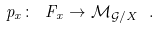<formula> <loc_0><loc_0><loc_500><loc_500>p _ { x } \colon \ F _ { x } \to \mathcal { M } _ { \mathcal { G } / X } \ .</formula> 